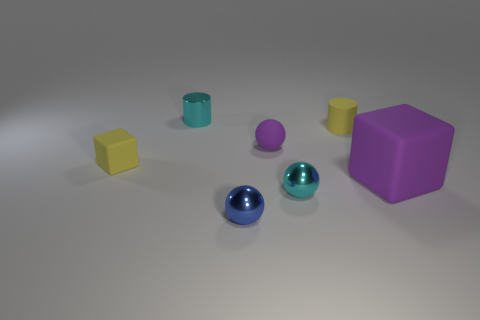Subtract all small metal balls. How many balls are left? 1 Add 3 small cyan things. How many objects exist? 10 Subtract 2 cylinders. How many cylinders are left? 0 Subtract all small purple metal spheres. Subtract all tiny blue metallic spheres. How many objects are left? 6 Add 1 yellow matte objects. How many yellow matte objects are left? 3 Add 7 matte cubes. How many matte cubes exist? 9 Subtract all cyan spheres. How many spheres are left? 2 Subtract 0 gray cubes. How many objects are left? 7 Subtract all cylinders. How many objects are left? 5 Subtract all gray cylinders. Subtract all red blocks. How many cylinders are left? 2 